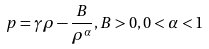<formula> <loc_0><loc_0><loc_500><loc_500>p = \gamma \rho - \frac { B } { \rho ^ { \alpha } } , B > 0 , 0 < \alpha < 1</formula> 